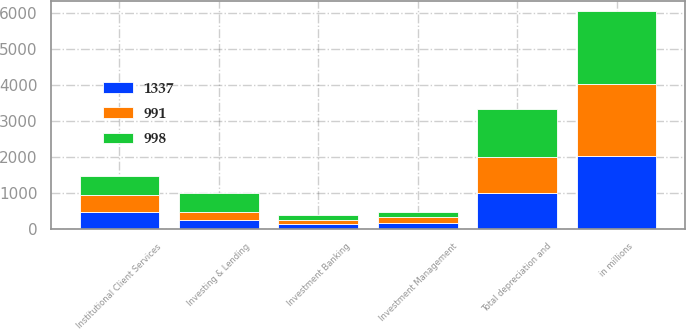Convert chart. <chart><loc_0><loc_0><loc_500><loc_500><stacked_bar_chart><ecel><fcel>in millions<fcel>Investment Banking<fcel>Institutional Client Services<fcel>Investing & Lending<fcel>Investment Management<fcel>Total depreciation and<nl><fcel>991<fcel>2016<fcel>126<fcel>489<fcel>215<fcel>168<fcel>998<nl><fcel>1337<fcel>2015<fcel>123<fcel>462<fcel>253<fcel>153<fcel>991<nl><fcel>998<fcel>2014<fcel>135<fcel>525<fcel>530<fcel>147<fcel>1337<nl></chart> 